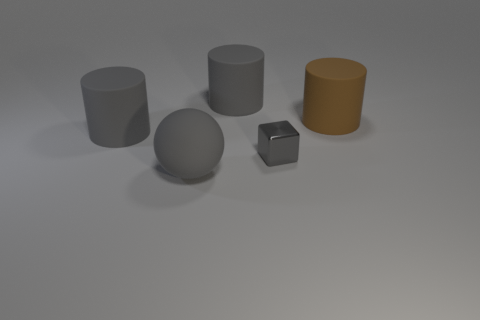Do the brown rubber cylinder and the gray rubber sphere have the same size?
Offer a terse response. Yes. What number of spheres are either brown rubber things or large yellow things?
Keep it short and to the point. 0. What material is the cube that is the same color as the matte ball?
Offer a very short reply. Metal. How many other matte objects have the same shape as the big brown object?
Offer a very short reply. 2. Are there more big objects that are in front of the brown thing than large gray rubber things that are on the right side of the gray shiny block?
Make the answer very short. Yes. Is the color of the large thing that is on the left side of the big gray sphere the same as the sphere?
Give a very brief answer. Yes. What is the size of the brown thing?
Provide a succinct answer. Large. There is a rubber object to the right of the tiny gray thing; what is its color?
Your answer should be very brief. Brown. How many tiny gray metallic cubes are there?
Provide a short and direct response. 1. There is a gray matte cylinder that is behind the large rubber cylinder that is to the right of the gray block; is there a big brown matte object behind it?
Provide a succinct answer. No. 